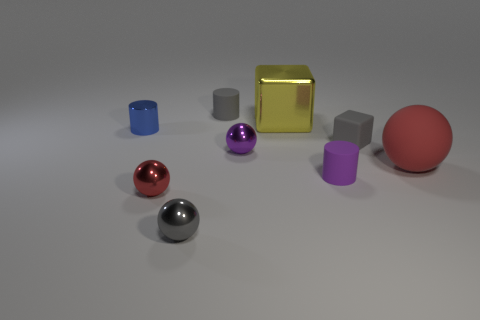Add 1 red balls. How many objects exist? 10 Subtract all small gray rubber cylinders. How many cylinders are left? 2 Subtract all yellow blocks. How many blocks are left? 1 Subtract all purple cubes. How many red balls are left? 2 Add 2 gray rubber cubes. How many gray rubber cubes are left? 3 Add 2 small gray rubber things. How many small gray rubber things exist? 4 Subtract 0 brown spheres. How many objects are left? 9 Subtract all cylinders. How many objects are left? 6 Subtract 2 blocks. How many blocks are left? 0 Subtract all cyan cylinders. Subtract all gray blocks. How many cylinders are left? 3 